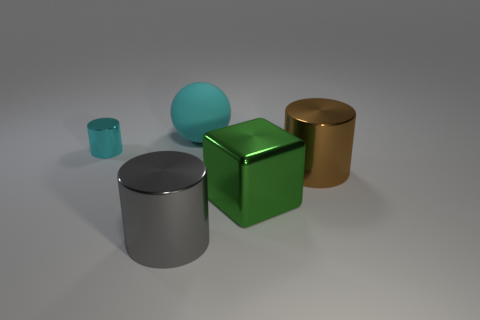What number of objects are either metal cylinders that are in front of the tiny cylinder or cylinders on the left side of the gray metal thing?
Offer a very short reply. 3. What number of large objects are on the right side of the cylinder in front of the brown cylinder?
Your answer should be compact. 3. The block that is the same material as the cyan cylinder is what color?
Provide a short and direct response. Green. Are there any brown cylinders that have the same size as the cyan matte sphere?
Provide a succinct answer. Yes. The other matte thing that is the same size as the green thing is what shape?
Your answer should be compact. Sphere. Is there another small thing that has the same shape as the gray thing?
Your response must be concise. Yes. Is the material of the sphere the same as the cylinder to the right of the cube?
Offer a terse response. No. Are there any large shiny things of the same color as the tiny metallic cylinder?
Make the answer very short. No. What number of other objects are there of the same material as the brown object?
Provide a succinct answer. 3. Does the sphere have the same color as the metallic cylinder behind the brown shiny cylinder?
Ensure brevity in your answer.  Yes. 